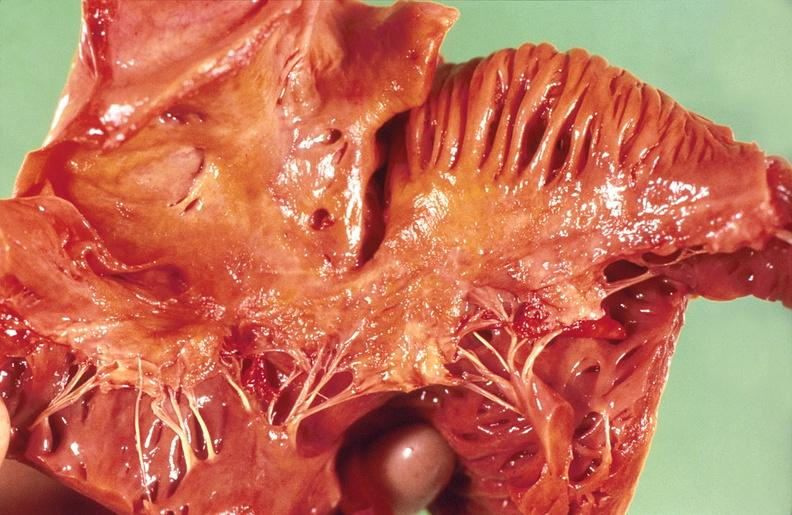what is present?
Answer the question using a single word or phrase. Cardiovascular 